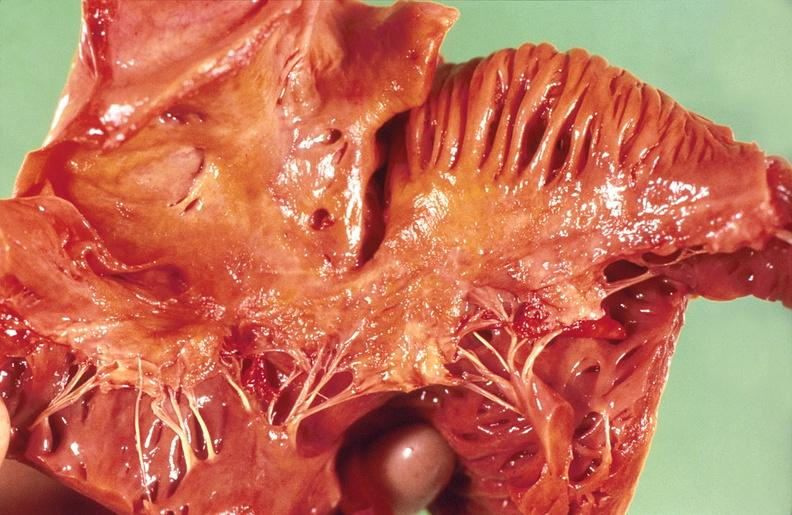what is present?
Answer the question using a single word or phrase. Cardiovascular 